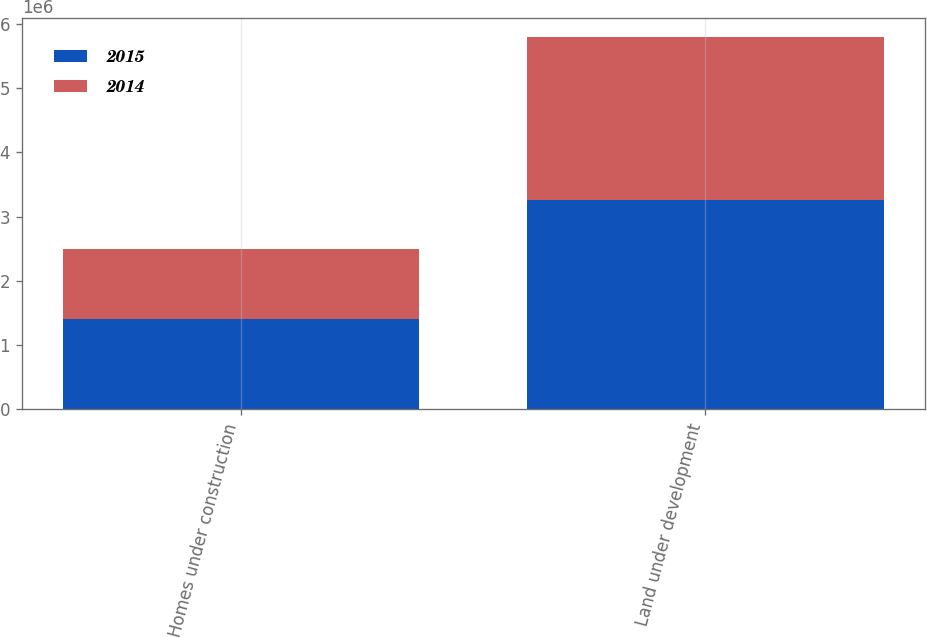Convert chart. <chart><loc_0><loc_0><loc_500><loc_500><stacked_bar_chart><ecel><fcel>Homes under construction<fcel>Land under development<nl><fcel>2015<fcel>1.40826e+06<fcel>3.25907e+06<nl><fcel>2014<fcel>1.08414e+06<fcel>2.54505e+06<nl></chart> 